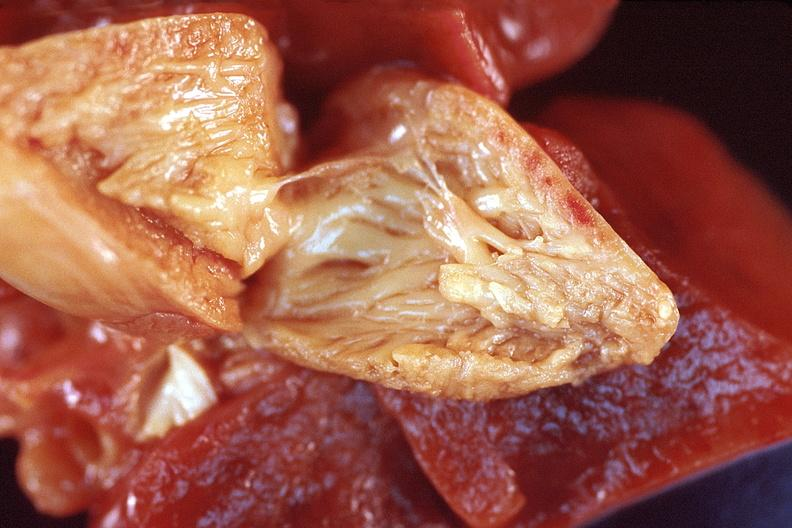why does this image show heart, right ventricular enlargement?
Answer the question using a single word or phrase. Due to a patent ductus arteriosis in a patient with hyaline membrane disease 